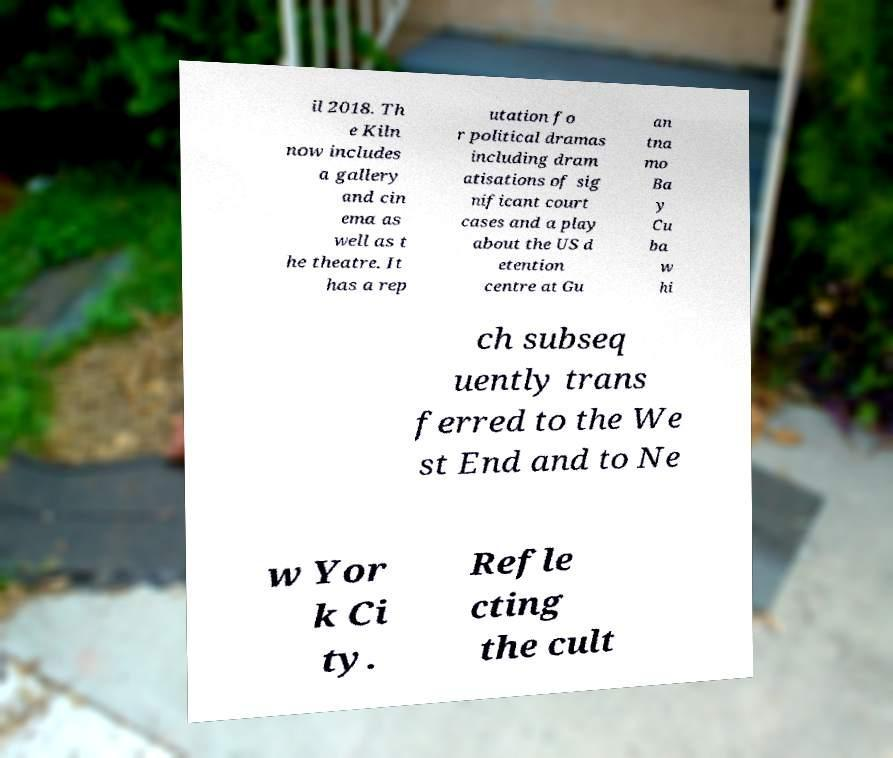What messages or text are displayed in this image? I need them in a readable, typed format. il 2018. Th e Kiln now includes a gallery and cin ema as well as t he theatre. It has a rep utation fo r political dramas including dram atisations of sig nificant court cases and a play about the US d etention centre at Gu an tna mo Ba y Cu ba w hi ch subseq uently trans ferred to the We st End and to Ne w Yor k Ci ty. Refle cting the cult 